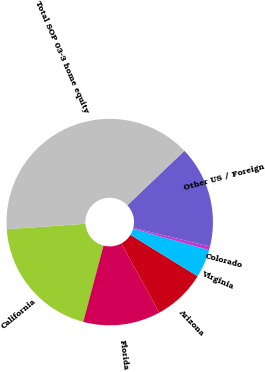<chart> <loc_0><loc_0><loc_500><loc_500><pie_chart><fcel>California<fcel>Florida<fcel>Arizona<fcel>Virginia<fcel>Colorado<fcel>Other US / Foreign<fcel>Total SOP 03-3 home equity<nl><fcel>19.77%<fcel>12.09%<fcel>8.25%<fcel>4.41%<fcel>0.57%<fcel>15.93%<fcel>38.97%<nl></chart> 